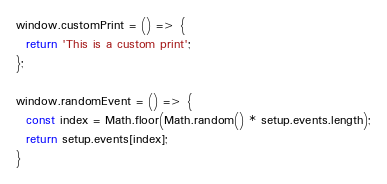<code> <loc_0><loc_0><loc_500><loc_500><_JavaScript_>window.customPrint = () => {
  return 'This is a custom print';
};

window.randomEvent = () => {
  const index = Math.floor(Math.random() * setup.events.length);
  return setup.events[index];
}
</code> 